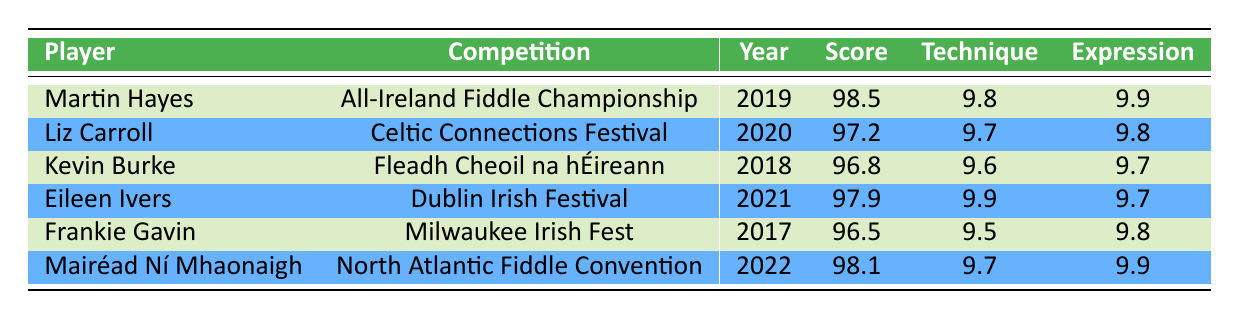What was the highest score achieved in the competitions listed? The table shows that Martin Hayes achieved the highest score of 98.5 in the All-Ireland Fiddle Championship in 2019.
Answer: 98.5 Which player's technique rating was the lowest? The technique rating for each player is listed in the table. Frankie Gavin had the lowest technique rating of 9.5 in the Milwaukee Irish Fest in 2017.
Answer: 9.5 Did Eileen Ivers compete in a competition before 2020? Looking at the year column, Eileen Ivers competed in 2021, which is after 2020. Thus, the answer is no.
Answer: No What is the average audience appeal rating for the players? To find the average, add all audience appeal ratings together: (9.7 + 9.6 + 9.8 + 9.9 + 9.7 + 9.8) = 58.5. There are 6 players, so the average is 58.5 / 6 = 9.75.
Answer: 9.75 Which player had the highest expression rating? By comparing the expression ratings in the table, both Martin Hayes and Mairéad Ní Mhaonaigh have the highest expression rating of 9.9 each.
Answer: 9.9 In what year did Kevin Burke compete? The table directly shows that Kevin Burke competed in the Fleadh Cheoil na hÉireann in 2018.
Answer: 2018 Is it true that Liz Carroll's overall score is higher than Frankie Gavin's? Comparing the scores, Liz Carroll scored 97.2 while Frankie Gavin scored 96.5. Since 97.2 is greater than 96.5, the statement is true.
Answer: Yes What is the difference between the highest and lowest scores in the table? The highest score is 98.5 (Martin Hayes) and the lowest score is 96.5 (Frankie Gavin). The difference is calculated as 98.5 - 96.5 = 2.
Answer: 2 